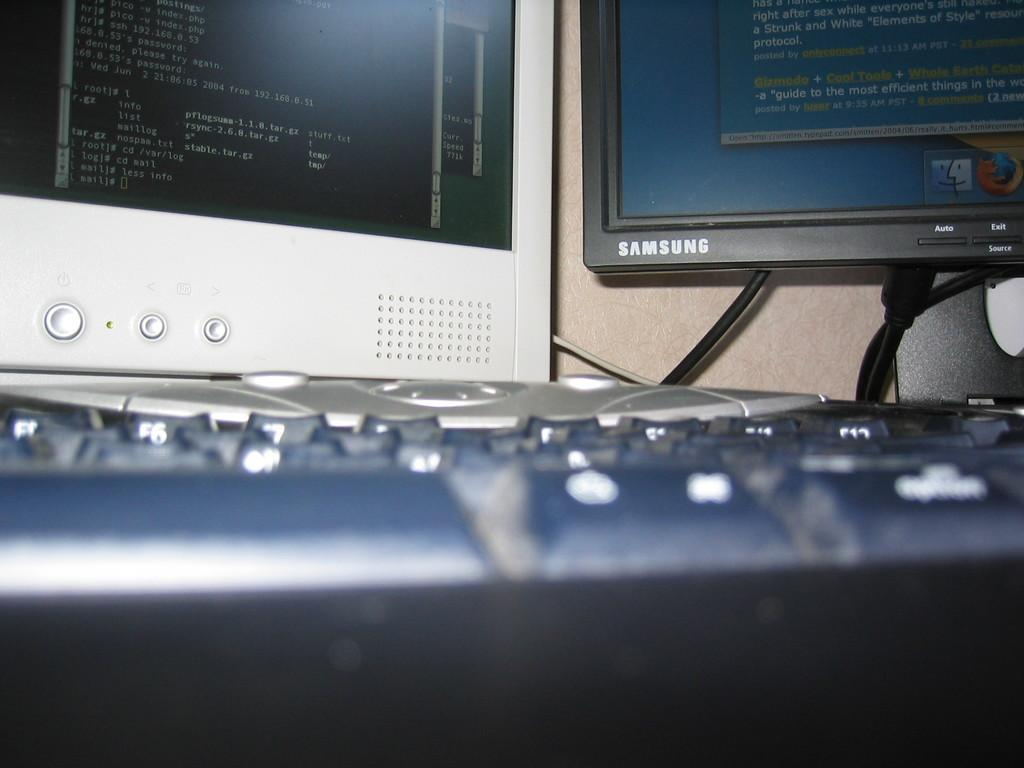<image>
Present a compact description of the photo's key features. A Samsung screen with information on its screen. 